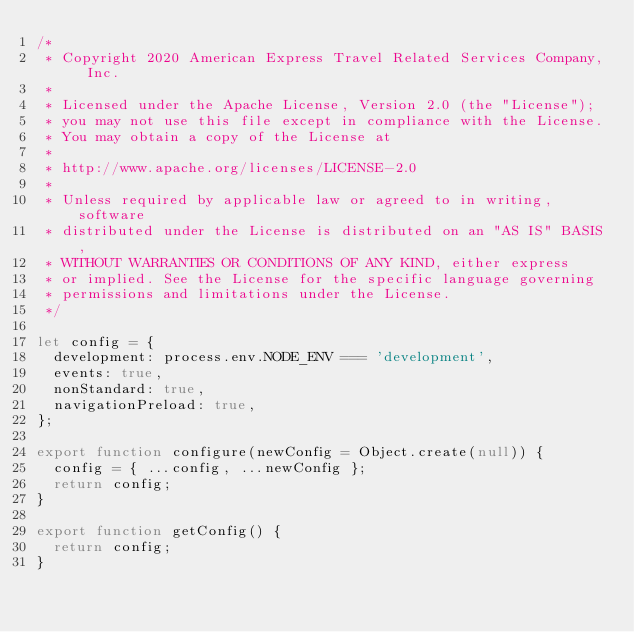Convert code to text. <code><loc_0><loc_0><loc_500><loc_500><_JavaScript_>/*
 * Copyright 2020 American Express Travel Related Services Company, Inc.
 *
 * Licensed under the Apache License, Version 2.0 (the "License");
 * you may not use this file except in compliance with the License.
 * You may obtain a copy of the License at
 *
 * http://www.apache.org/licenses/LICENSE-2.0
 *
 * Unless required by applicable law or agreed to in writing, software
 * distributed under the License is distributed on an "AS IS" BASIS,
 * WITHOUT WARRANTIES OR CONDITIONS OF ANY KIND, either express
 * or implied. See the License for the specific language governing
 * permissions and limitations under the License.
 */

let config = {
  development: process.env.NODE_ENV === 'development',
  events: true,
  nonStandard: true,
  navigationPreload: true,
};

export function configure(newConfig = Object.create(null)) {
  config = { ...config, ...newConfig };
  return config;
}

export function getConfig() {
  return config;
}
</code> 